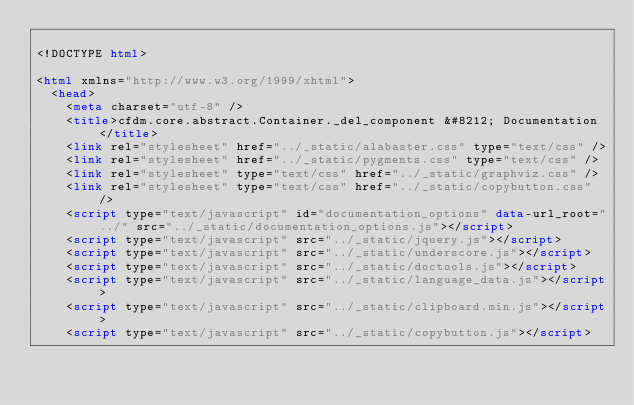<code> <loc_0><loc_0><loc_500><loc_500><_HTML_>
<!DOCTYPE html>

<html xmlns="http://www.w3.org/1999/xhtml">
  <head>
    <meta charset="utf-8" />
    <title>cfdm.core.abstract.Container._del_component &#8212; Documentation</title>
    <link rel="stylesheet" href="../_static/alabaster.css" type="text/css" />
    <link rel="stylesheet" href="../_static/pygments.css" type="text/css" />
    <link rel="stylesheet" type="text/css" href="../_static/graphviz.css" />
    <link rel="stylesheet" type="text/css" href="../_static/copybutton.css" />
    <script type="text/javascript" id="documentation_options" data-url_root="../" src="../_static/documentation_options.js"></script>
    <script type="text/javascript" src="../_static/jquery.js"></script>
    <script type="text/javascript" src="../_static/underscore.js"></script>
    <script type="text/javascript" src="../_static/doctools.js"></script>
    <script type="text/javascript" src="../_static/language_data.js"></script>
    <script type="text/javascript" src="../_static/clipboard.min.js"></script>
    <script type="text/javascript" src="../_static/copybutton.js"></script></code> 